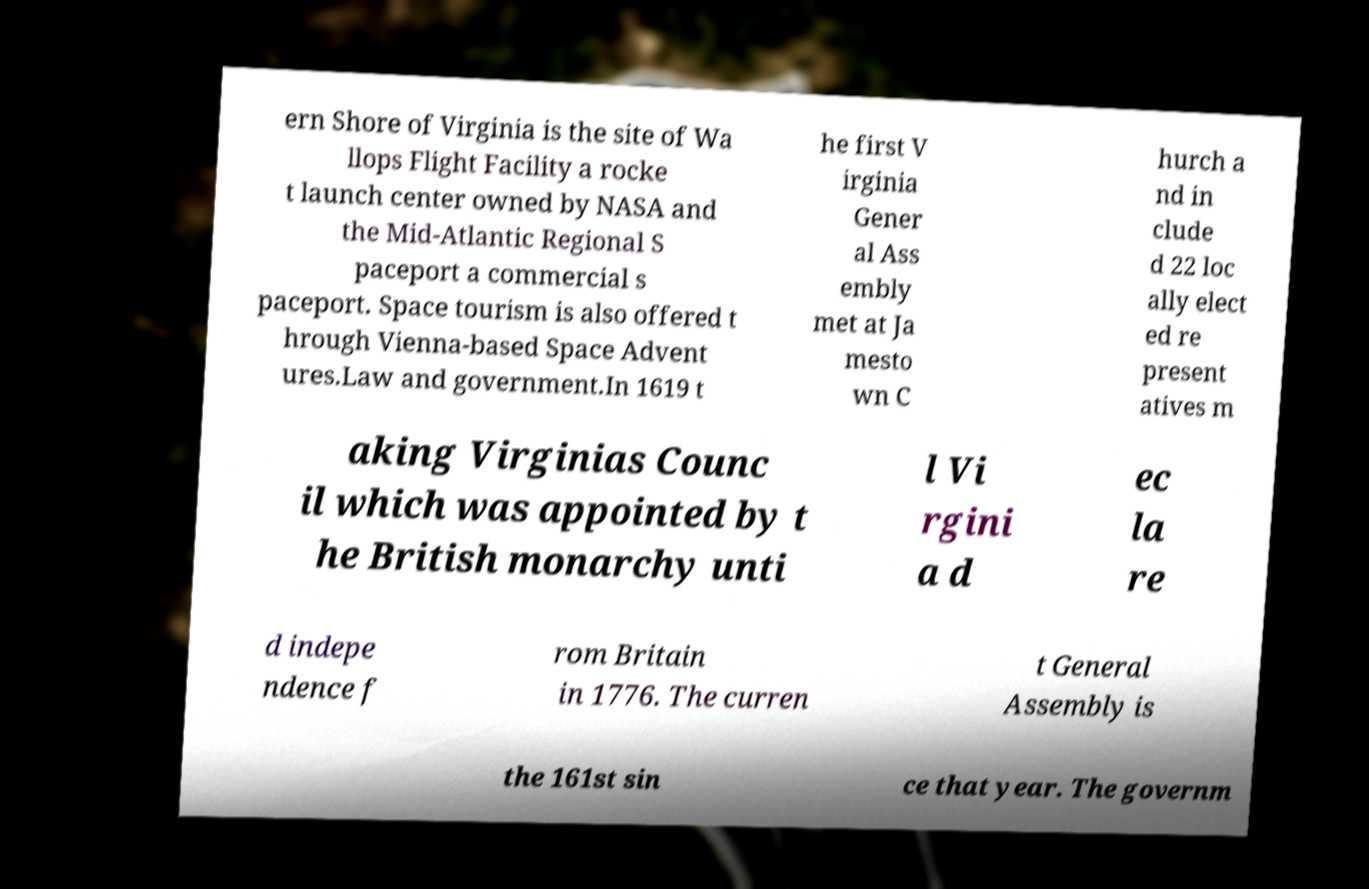Could you extract and type out the text from this image? ern Shore of Virginia is the site of Wa llops Flight Facility a rocke t launch center owned by NASA and the Mid-Atlantic Regional S paceport a commercial s paceport. Space tourism is also offered t hrough Vienna-based Space Advent ures.Law and government.In 1619 t he first V irginia Gener al Ass embly met at Ja mesto wn C hurch a nd in clude d 22 loc ally elect ed re present atives m aking Virginias Counc il which was appointed by t he British monarchy unti l Vi rgini a d ec la re d indepe ndence f rom Britain in 1776. The curren t General Assembly is the 161st sin ce that year. The governm 